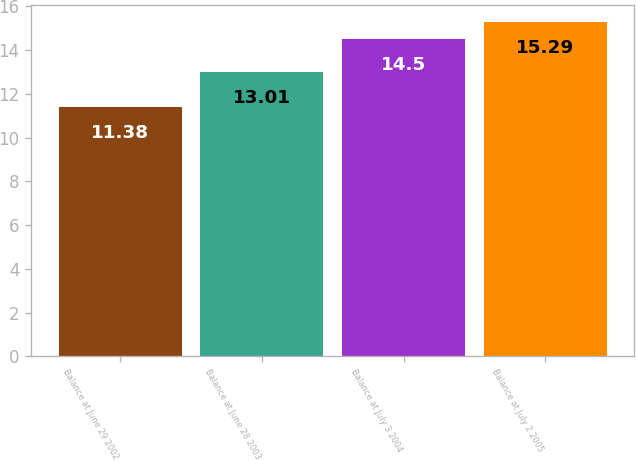<chart> <loc_0><loc_0><loc_500><loc_500><bar_chart><fcel>Balance at June 29 2002<fcel>Balance at June 28 2003<fcel>Balance at July 3 2004<fcel>Balance at July 2 2005<nl><fcel>11.38<fcel>13.01<fcel>14.5<fcel>15.29<nl></chart> 